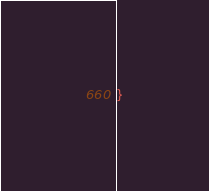Convert code to text. <code><loc_0><loc_0><loc_500><loc_500><_CSS_>}
</code> 